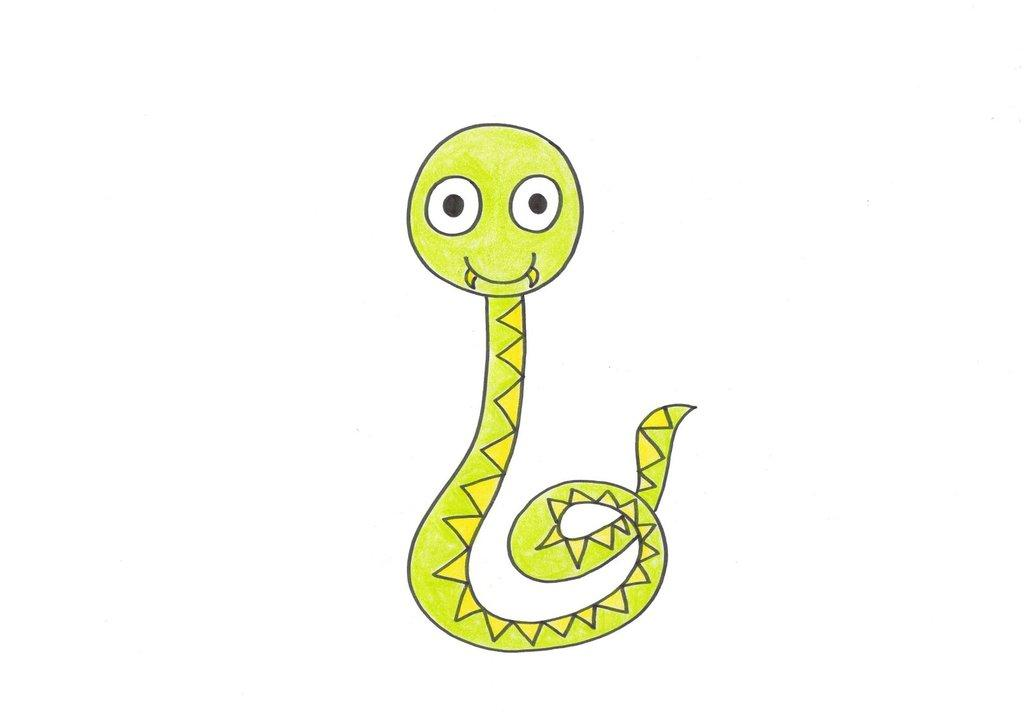What is the main subject of the image? There is a sketch in the image. What color is the background of the image? The background of the image is white. What type of dress is being worn by the person in the sketch? There is no person or dress present in the image, as it only contains a sketch. 